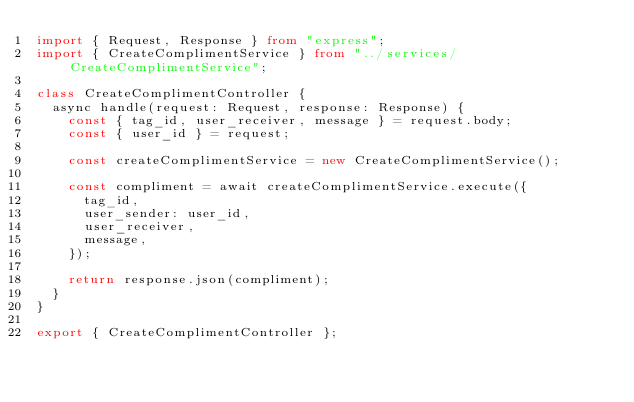Convert code to text. <code><loc_0><loc_0><loc_500><loc_500><_TypeScript_>import { Request, Response } from "express";
import { CreateComplimentService } from "../services/CreateComplimentService";

class CreateComplimentController {
	async handle(request: Request, response: Response) {
		const { tag_id, user_receiver, message } = request.body;
		const { user_id } = request;

		const createComplimentService = new CreateComplimentService();

		const compliment = await createComplimentService.execute({
			tag_id,
			user_sender: user_id,
			user_receiver,
			message,
		});

		return response.json(compliment);
	}
}

export { CreateComplimentController };
</code> 